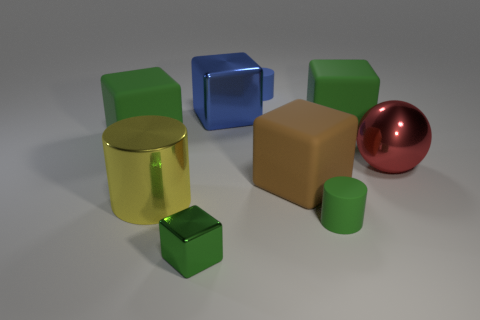Subtract all green cubes. How many were subtracted if there are1green cubes left? 2 Subtract all purple spheres. How many green blocks are left? 3 Subtract all brown cubes. How many cubes are left? 4 Subtract all blue metal cubes. How many cubes are left? 4 Add 1 yellow shiny cylinders. How many objects exist? 10 Subtract all gray cubes. Subtract all blue balls. How many cubes are left? 5 Subtract all cylinders. How many objects are left? 6 Subtract all large cylinders. Subtract all tiny green rubber cylinders. How many objects are left? 7 Add 9 big metal cylinders. How many big metal cylinders are left? 10 Add 8 blue cylinders. How many blue cylinders exist? 9 